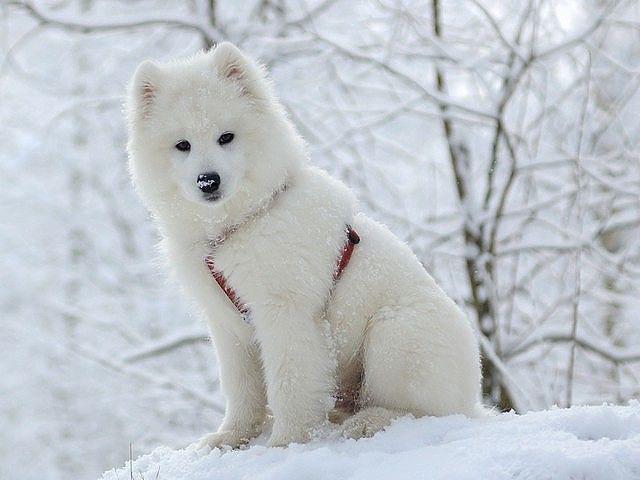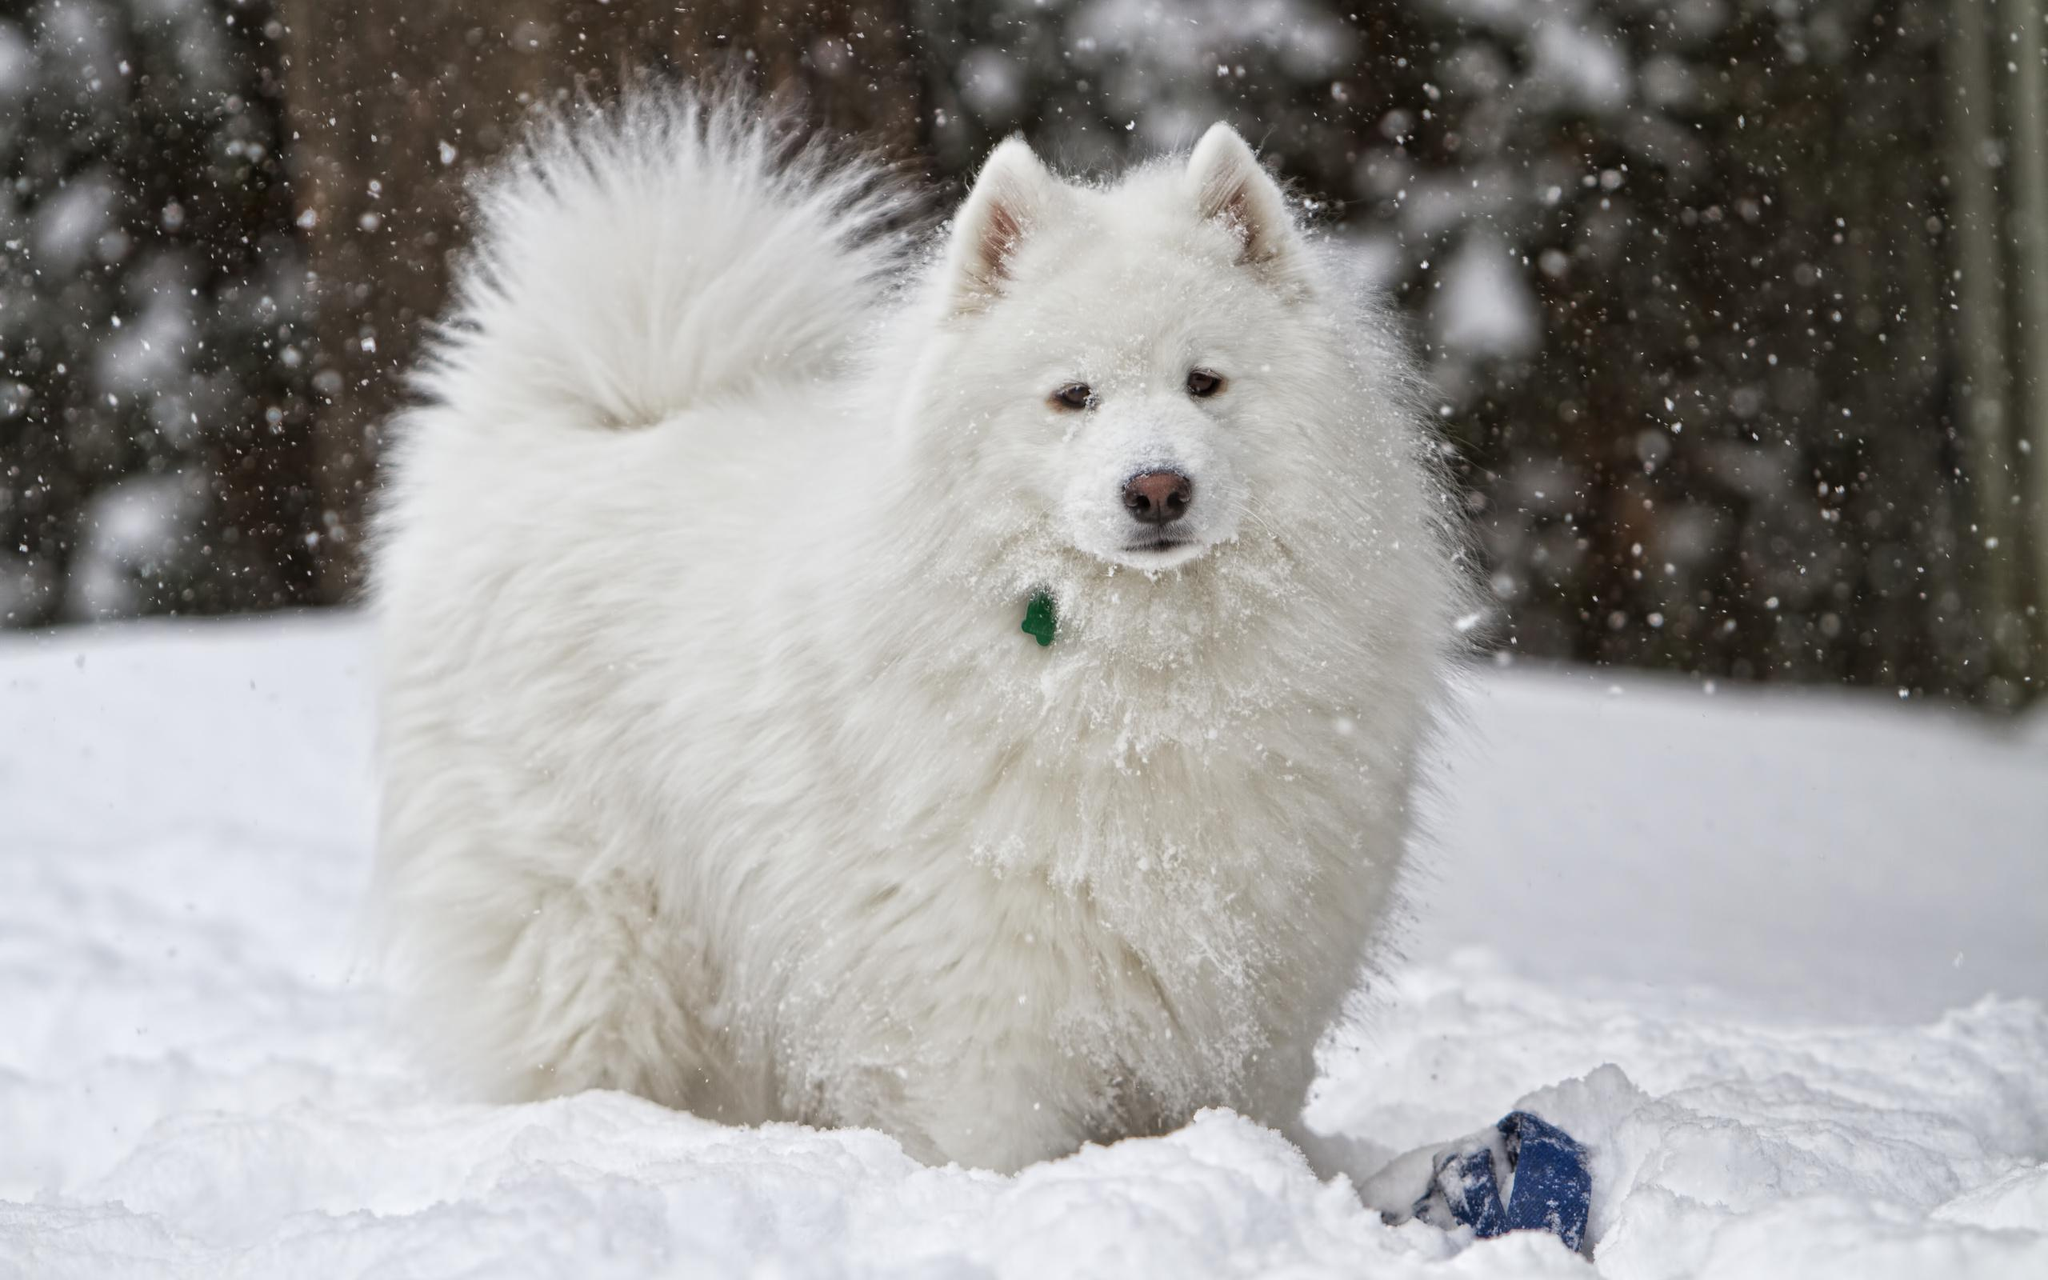The first image is the image on the left, the second image is the image on the right. Evaluate the accuracy of this statement regarding the images: "An image shows a white dog wearing a harness in a wintry scene.". Is it true? Answer yes or no. Yes. The first image is the image on the left, the second image is the image on the right. Examine the images to the left and right. Is the description "Exactly two large white dogs are shown in snowy outdoor areas with trees in the background, one of them wearing a harness." accurate? Answer yes or no. Yes. 